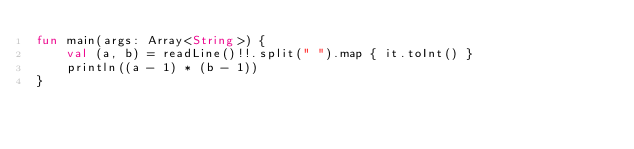<code> <loc_0><loc_0><loc_500><loc_500><_Kotlin_>fun main(args: Array<String>) {
    val (a, b) = readLine()!!.split(" ").map { it.toInt() }
    println((a - 1) * (b - 1))
}
</code> 